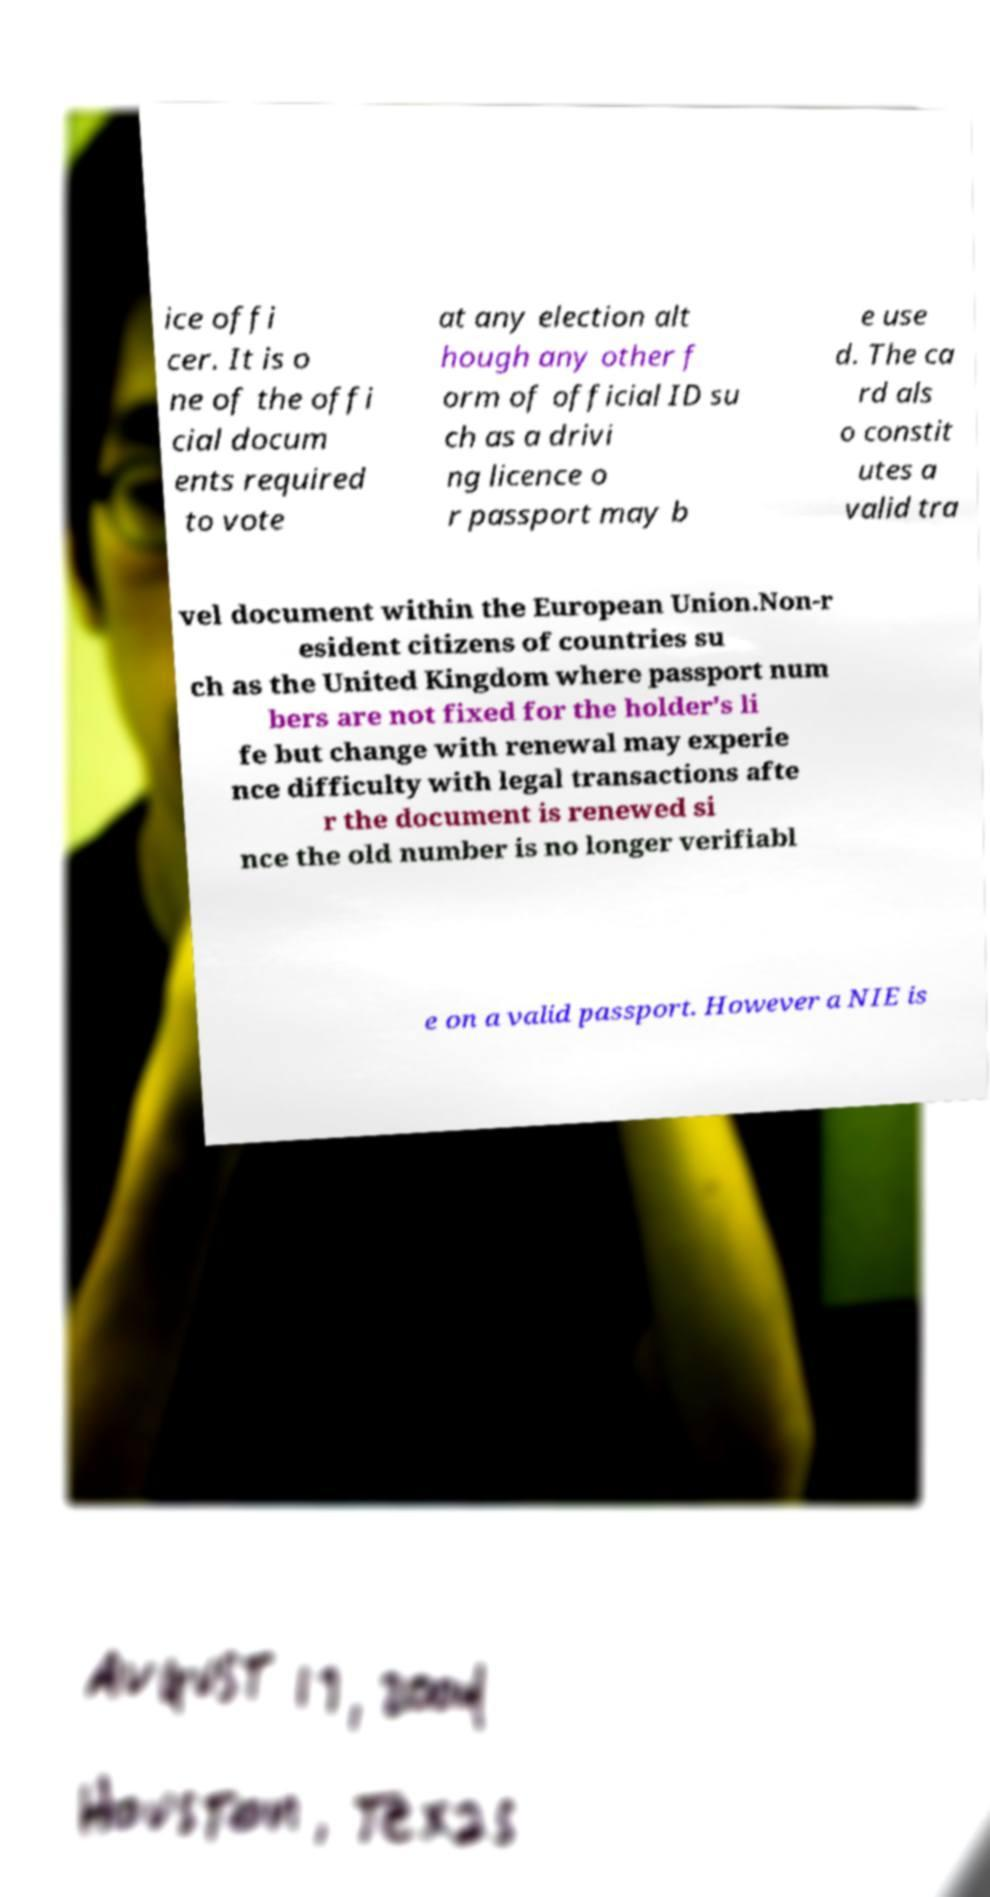For documentation purposes, I need the text within this image transcribed. Could you provide that? ice offi cer. It is o ne of the offi cial docum ents required to vote at any election alt hough any other f orm of official ID su ch as a drivi ng licence o r passport may b e use d. The ca rd als o constit utes a valid tra vel document within the European Union.Non-r esident citizens of countries su ch as the United Kingdom where passport num bers are not fixed for the holder's li fe but change with renewal may experie nce difficulty with legal transactions afte r the document is renewed si nce the old number is no longer verifiabl e on a valid passport. However a NIE is 